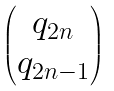<formula> <loc_0><loc_0><loc_500><loc_500>\begin{pmatrix} q _ { 2 n } \\ q _ { 2 n - 1 } \end{pmatrix}</formula> 